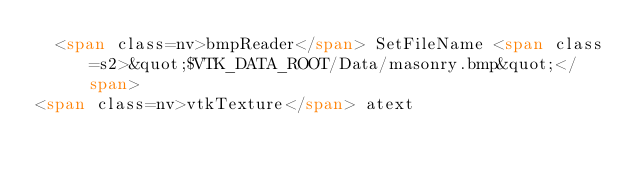Convert code to text. <code><loc_0><loc_0><loc_500><loc_500><_HTML_>  <span class=nv>bmpReader</span> SetFileName <span class=s2>&quot;$VTK_DATA_ROOT/Data/masonry.bmp&quot;</span>
<span class=nv>vtkTexture</span> atext</code> 